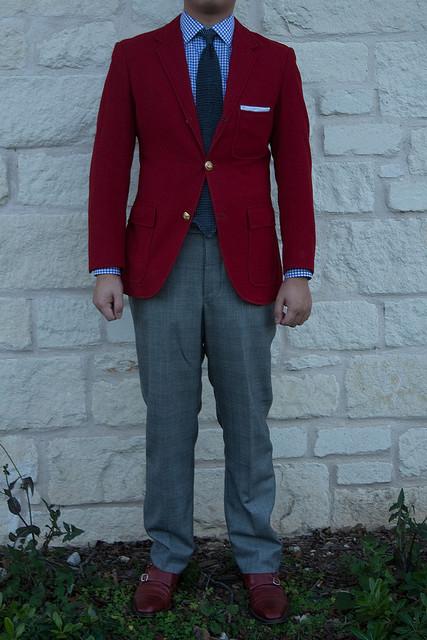Does his suit match?
Write a very short answer. No. Is this man's tie properly tied?
Quick response, please. Yes. Why is his head cut off from the picture?
Write a very short answer. Yes. Do his shoes match his jacket?
Concise answer only. Yes. What color are the pants?
Keep it brief. Gray. Do the shoes have buckles?
Give a very brief answer. Yes. Is the picture in color?
Answer briefly. Yes. 